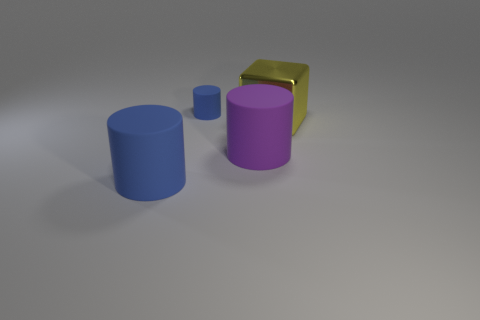Subtract all large cylinders. How many cylinders are left? 1 Subtract all green cubes. How many blue cylinders are left? 2 Add 3 big blue rubber things. How many objects exist? 7 Subtract all cubes. How many objects are left? 3 Add 2 cylinders. How many cylinders are left? 5 Add 1 cyan balls. How many cyan balls exist? 1 Subtract 0 cyan cubes. How many objects are left? 4 Subtract all blue objects. Subtract all big purple objects. How many objects are left? 1 